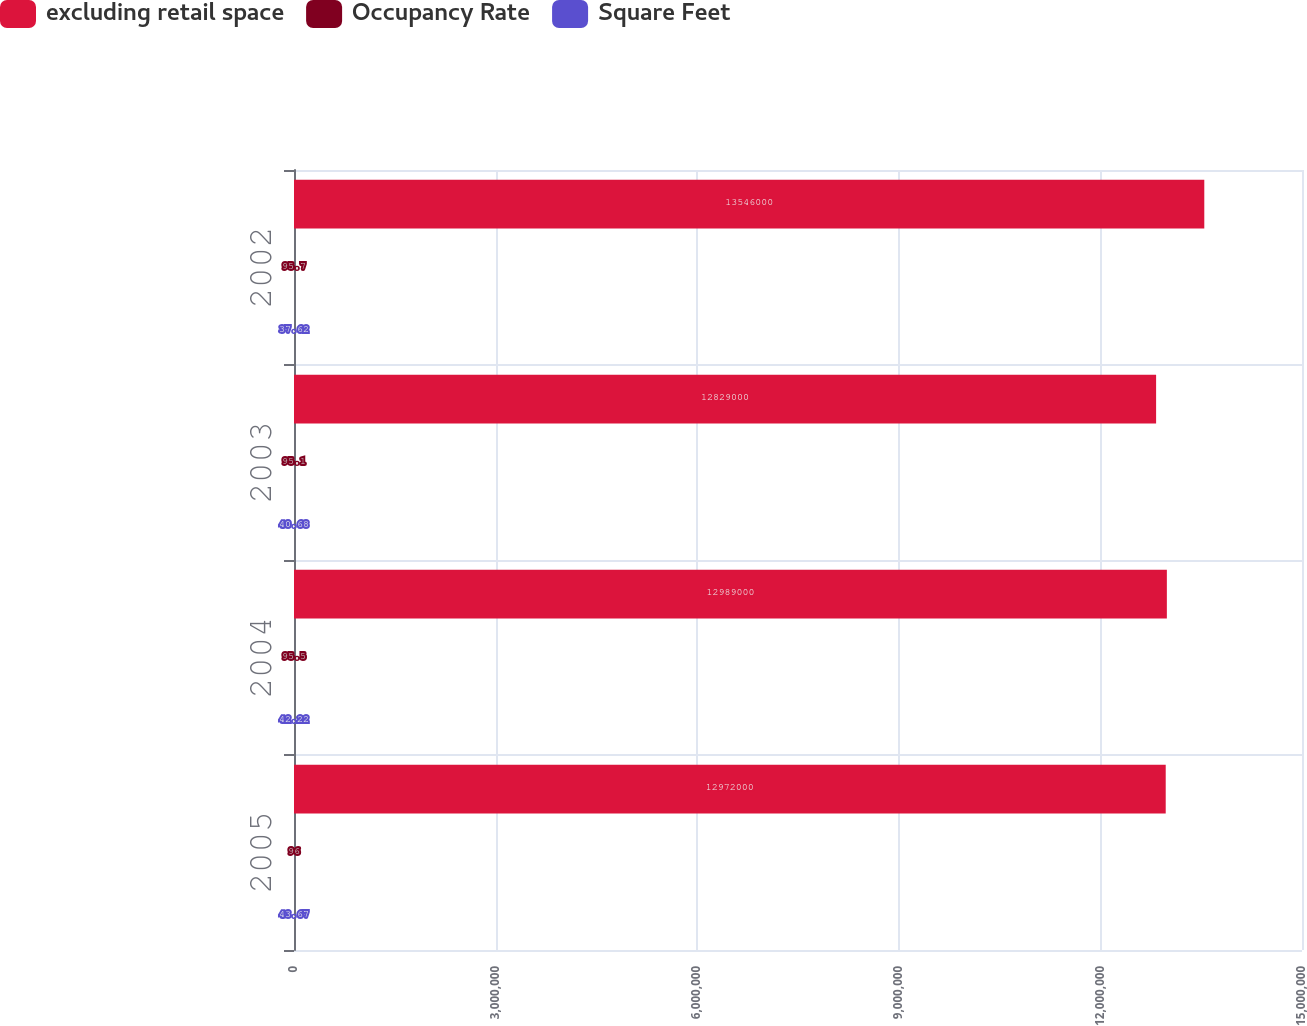Convert chart. <chart><loc_0><loc_0><loc_500><loc_500><stacked_bar_chart><ecel><fcel>2005<fcel>2004<fcel>2003<fcel>2002<nl><fcel>excluding retail space<fcel>1.2972e+07<fcel>1.2989e+07<fcel>1.2829e+07<fcel>1.3546e+07<nl><fcel>Occupancy Rate<fcel>96<fcel>95.5<fcel>95.1<fcel>95.7<nl><fcel>Square Feet<fcel>43.67<fcel>42.22<fcel>40.68<fcel>37.62<nl></chart> 